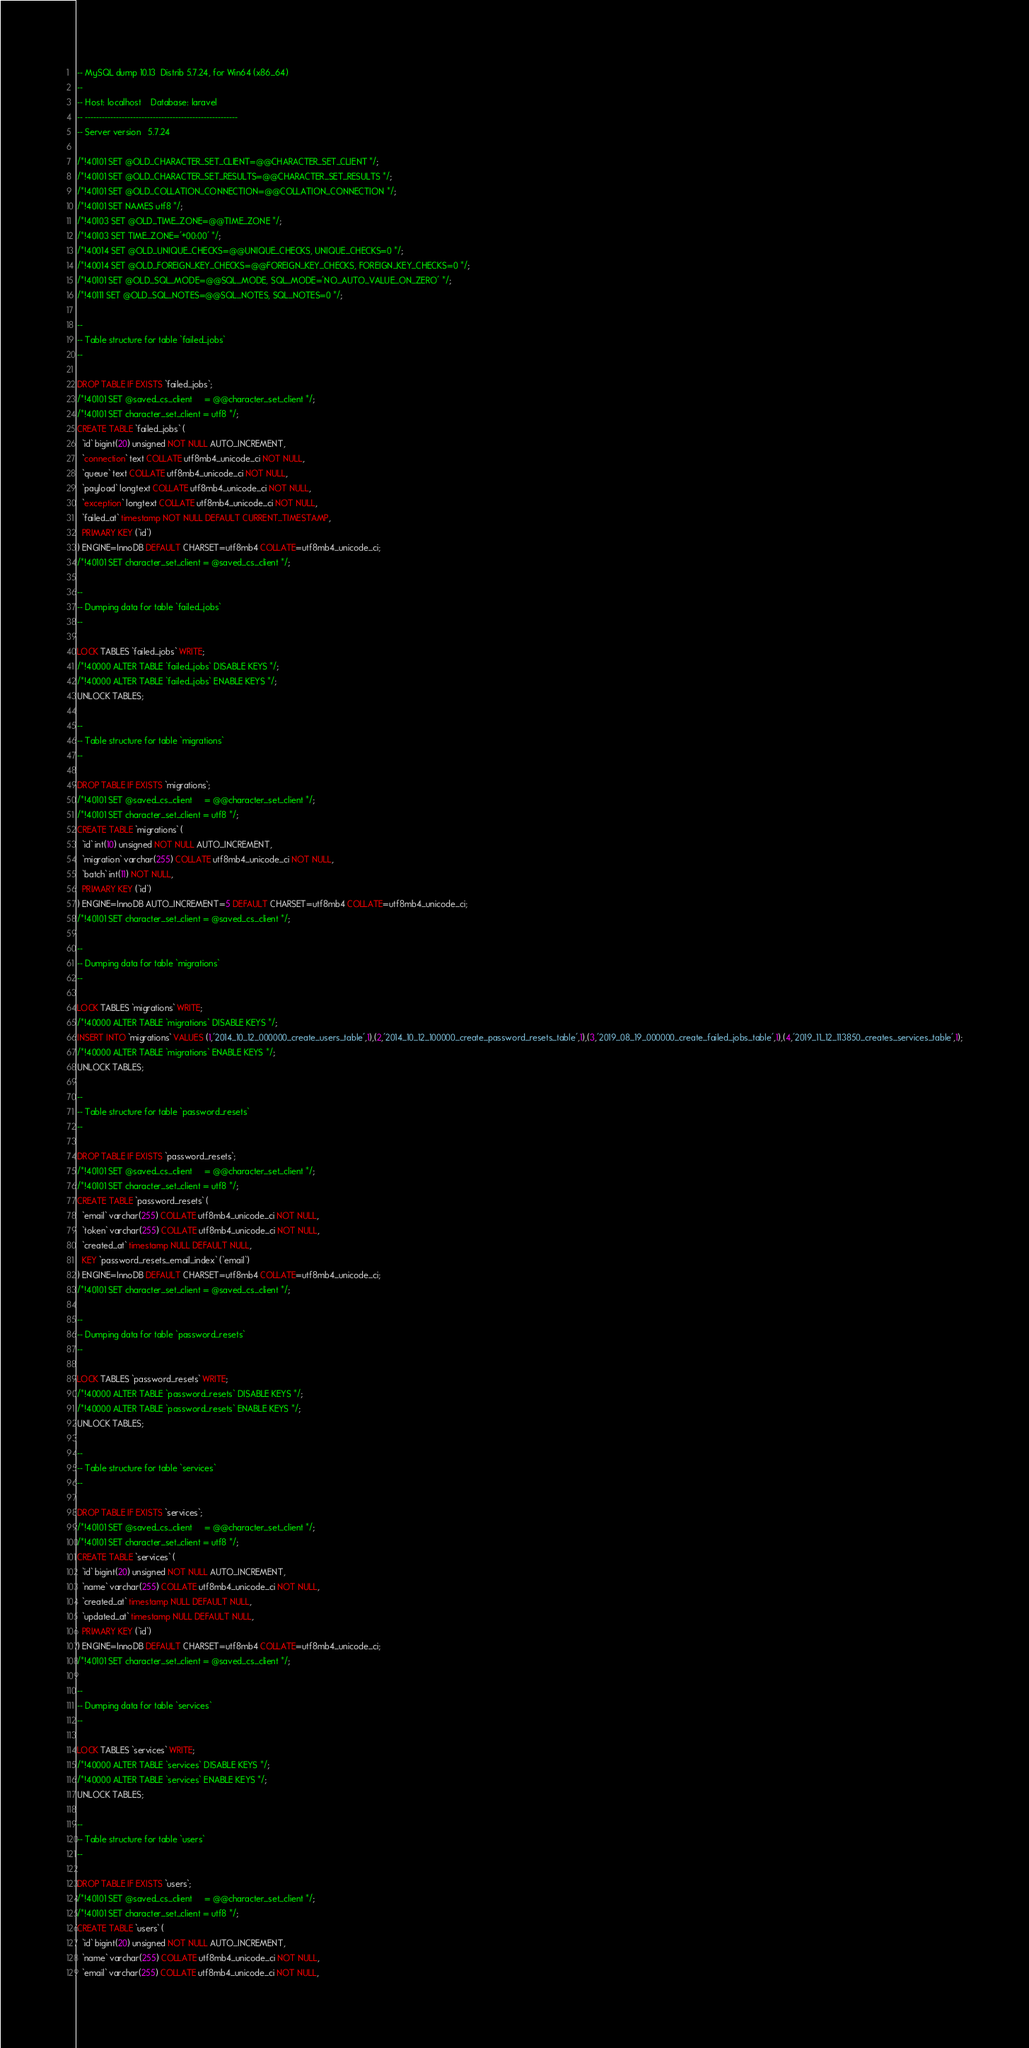<code> <loc_0><loc_0><loc_500><loc_500><_SQL_>-- MySQL dump 10.13  Distrib 5.7.24, for Win64 (x86_64)
--
-- Host: localhost    Database: laravel
-- ------------------------------------------------------
-- Server version	5.7.24

/*!40101 SET @OLD_CHARACTER_SET_CLIENT=@@CHARACTER_SET_CLIENT */;
/*!40101 SET @OLD_CHARACTER_SET_RESULTS=@@CHARACTER_SET_RESULTS */;
/*!40101 SET @OLD_COLLATION_CONNECTION=@@COLLATION_CONNECTION */;
/*!40101 SET NAMES utf8 */;
/*!40103 SET @OLD_TIME_ZONE=@@TIME_ZONE */;
/*!40103 SET TIME_ZONE='+00:00' */;
/*!40014 SET @OLD_UNIQUE_CHECKS=@@UNIQUE_CHECKS, UNIQUE_CHECKS=0 */;
/*!40014 SET @OLD_FOREIGN_KEY_CHECKS=@@FOREIGN_KEY_CHECKS, FOREIGN_KEY_CHECKS=0 */;
/*!40101 SET @OLD_SQL_MODE=@@SQL_MODE, SQL_MODE='NO_AUTO_VALUE_ON_ZERO' */;
/*!40111 SET @OLD_SQL_NOTES=@@SQL_NOTES, SQL_NOTES=0 */;

--
-- Table structure for table `failed_jobs`
--

DROP TABLE IF EXISTS `failed_jobs`;
/*!40101 SET @saved_cs_client     = @@character_set_client */;
/*!40101 SET character_set_client = utf8 */;
CREATE TABLE `failed_jobs` (
  `id` bigint(20) unsigned NOT NULL AUTO_INCREMENT,
  `connection` text COLLATE utf8mb4_unicode_ci NOT NULL,
  `queue` text COLLATE utf8mb4_unicode_ci NOT NULL,
  `payload` longtext COLLATE utf8mb4_unicode_ci NOT NULL,
  `exception` longtext COLLATE utf8mb4_unicode_ci NOT NULL,
  `failed_at` timestamp NOT NULL DEFAULT CURRENT_TIMESTAMP,
  PRIMARY KEY (`id`)
) ENGINE=InnoDB DEFAULT CHARSET=utf8mb4 COLLATE=utf8mb4_unicode_ci;
/*!40101 SET character_set_client = @saved_cs_client */;

--
-- Dumping data for table `failed_jobs`
--

LOCK TABLES `failed_jobs` WRITE;
/*!40000 ALTER TABLE `failed_jobs` DISABLE KEYS */;
/*!40000 ALTER TABLE `failed_jobs` ENABLE KEYS */;
UNLOCK TABLES;

--
-- Table structure for table `migrations`
--

DROP TABLE IF EXISTS `migrations`;
/*!40101 SET @saved_cs_client     = @@character_set_client */;
/*!40101 SET character_set_client = utf8 */;
CREATE TABLE `migrations` (
  `id` int(10) unsigned NOT NULL AUTO_INCREMENT,
  `migration` varchar(255) COLLATE utf8mb4_unicode_ci NOT NULL,
  `batch` int(11) NOT NULL,
  PRIMARY KEY (`id`)
) ENGINE=InnoDB AUTO_INCREMENT=5 DEFAULT CHARSET=utf8mb4 COLLATE=utf8mb4_unicode_ci;
/*!40101 SET character_set_client = @saved_cs_client */;

--
-- Dumping data for table `migrations`
--

LOCK TABLES `migrations` WRITE;
/*!40000 ALTER TABLE `migrations` DISABLE KEYS */;
INSERT INTO `migrations` VALUES (1,'2014_10_12_000000_create_users_table',1),(2,'2014_10_12_100000_create_password_resets_table',1),(3,'2019_08_19_000000_create_failed_jobs_table',1),(4,'2019_11_12_113850_creates_services_table',1);
/*!40000 ALTER TABLE `migrations` ENABLE KEYS */;
UNLOCK TABLES;

--
-- Table structure for table `password_resets`
--

DROP TABLE IF EXISTS `password_resets`;
/*!40101 SET @saved_cs_client     = @@character_set_client */;
/*!40101 SET character_set_client = utf8 */;
CREATE TABLE `password_resets` (
  `email` varchar(255) COLLATE utf8mb4_unicode_ci NOT NULL,
  `token` varchar(255) COLLATE utf8mb4_unicode_ci NOT NULL,
  `created_at` timestamp NULL DEFAULT NULL,
  KEY `password_resets_email_index` (`email`)
) ENGINE=InnoDB DEFAULT CHARSET=utf8mb4 COLLATE=utf8mb4_unicode_ci;
/*!40101 SET character_set_client = @saved_cs_client */;

--
-- Dumping data for table `password_resets`
--

LOCK TABLES `password_resets` WRITE;
/*!40000 ALTER TABLE `password_resets` DISABLE KEYS */;
/*!40000 ALTER TABLE `password_resets` ENABLE KEYS */;
UNLOCK TABLES;

--
-- Table structure for table `services`
--

DROP TABLE IF EXISTS `services`;
/*!40101 SET @saved_cs_client     = @@character_set_client */;
/*!40101 SET character_set_client = utf8 */;
CREATE TABLE `services` (
  `id` bigint(20) unsigned NOT NULL AUTO_INCREMENT,
  `name` varchar(255) COLLATE utf8mb4_unicode_ci NOT NULL,
  `created_at` timestamp NULL DEFAULT NULL,
  `updated_at` timestamp NULL DEFAULT NULL,
  PRIMARY KEY (`id`)
) ENGINE=InnoDB DEFAULT CHARSET=utf8mb4 COLLATE=utf8mb4_unicode_ci;
/*!40101 SET character_set_client = @saved_cs_client */;

--
-- Dumping data for table `services`
--

LOCK TABLES `services` WRITE;
/*!40000 ALTER TABLE `services` DISABLE KEYS */;
/*!40000 ALTER TABLE `services` ENABLE KEYS */;
UNLOCK TABLES;

--
-- Table structure for table `users`
--

DROP TABLE IF EXISTS `users`;
/*!40101 SET @saved_cs_client     = @@character_set_client */;
/*!40101 SET character_set_client = utf8 */;
CREATE TABLE `users` (
  `id` bigint(20) unsigned NOT NULL AUTO_INCREMENT,
  `name` varchar(255) COLLATE utf8mb4_unicode_ci NOT NULL,
  `email` varchar(255) COLLATE utf8mb4_unicode_ci NOT NULL,</code> 